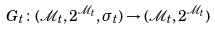<formula> <loc_0><loc_0><loc_500><loc_500>G _ { t } \colon ( \mathcal { M } _ { t } , 2 ^ { \mathcal { M } _ { t } } , \sigma _ { t } ) \to ( \mathcal { M } _ { t } , 2 ^ { \mathcal { M } _ { t } } )</formula> 